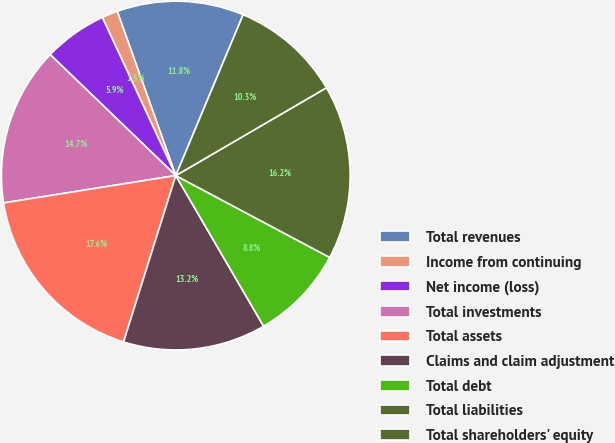Convert chart. <chart><loc_0><loc_0><loc_500><loc_500><pie_chart><fcel>Total revenues<fcel>Income from continuing<fcel>Net income (loss)<fcel>Total investments<fcel>Total assets<fcel>Claims and claim adjustment<fcel>Total debt<fcel>Total liabilities<fcel>Total shareholders' equity<nl><fcel>11.76%<fcel>1.47%<fcel>5.88%<fcel>14.71%<fcel>17.65%<fcel>13.24%<fcel>8.82%<fcel>16.18%<fcel>10.29%<nl></chart> 